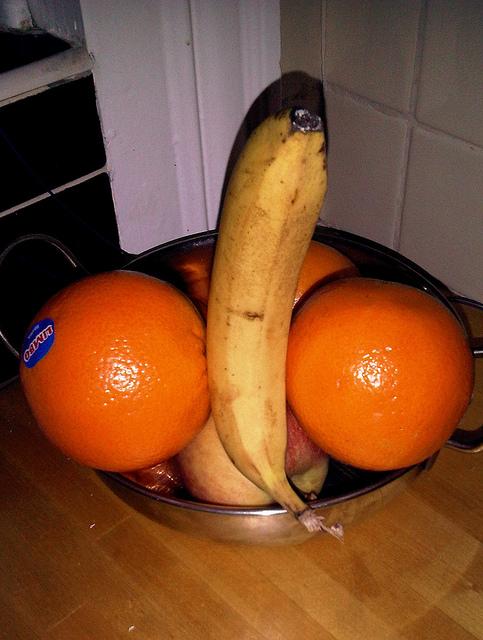Does this look like human genitalia?
Be succinct. Yes. How many oranges are seen?
Short answer required. 3. What color is the banana?
Short answer required. Yellow. 